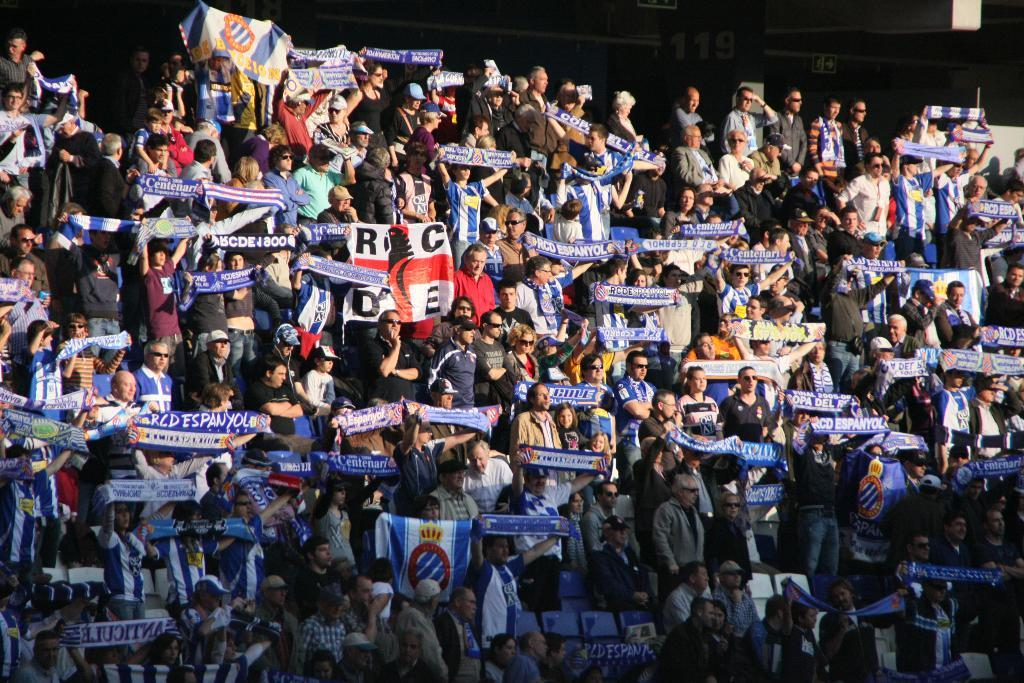What is the main subject of the image? The main subject of the image is a crowd of people. What are the people holding in the image? The people are holding blue color flags. What can be seen on the flags? There is text on the flags. Where might this image have been taken? It appears to be a stadium. What is the color of the background in the image? The background of the image is dark. What type of sponge is being used to clean the stadium floor in the image? There is no sponge visible in the image, and no cleaning activity is taking place. What news event is being discussed by the people in the image? There is no indication of a news event or discussion in the image; the people are holding flags and appear to be part of a gathering or event. 